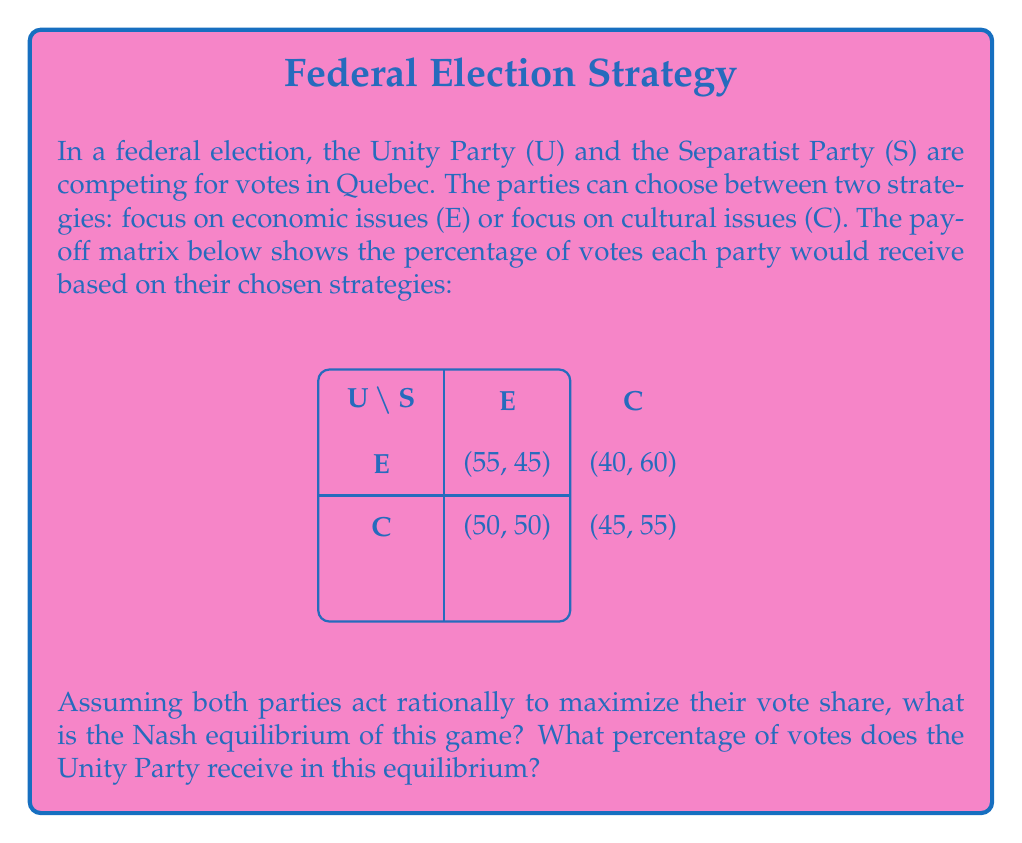Solve this math problem. To solve this problem, we need to follow these steps:

1) Identify the best responses for each party:

   For Unity Party (U):
   - If S chooses E, U's best response is E (55% > 50%)
   - If S chooses C, U's best response is E (40% < 45%)

   For Separatist Party (S):
   - If U chooses E, S's best response is C (45% < 60%)
   - If U chooses C, S's best response is C (50% < 55%)

2) Find the Nash equilibrium:
   A Nash equilibrium occurs when both parties are playing their best responses to each other's strategies. From our analysis, we can see that when U plays E and S plays C, both are playing their best responses. Therefore, (E, C) is the Nash equilibrium.

3) Calculate Unity Party's vote share in the equilibrium:
   When U plays E and S plays C, the payoff matrix shows that U receives 40% of the votes.

Therefore, the Nash equilibrium is (E, C), and in this equilibrium, the Unity Party receives 40% of the votes.
Answer: Nash equilibrium: (E, C); Unity Party's vote share: 40% 